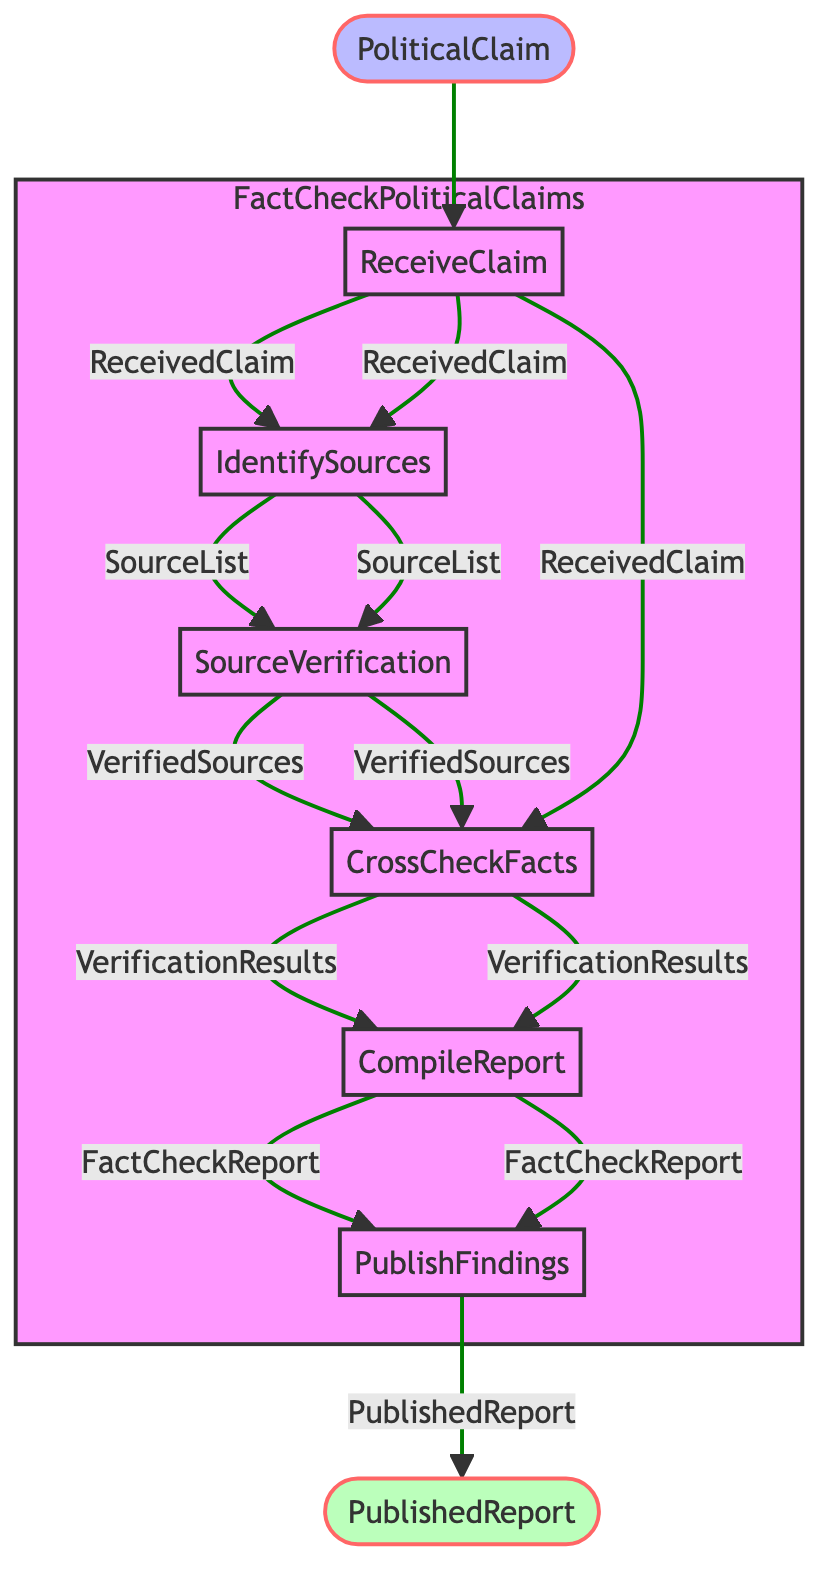What is the first step in the function? The first step listed in the diagram is "ReceiveClaim", which is indicated as the starting point.
Answer: ReceiveClaim How many outputs does the "CompileReport" step have? The "CompileReport" step produces one output, which is the "FactCheckReport".
Answer: One What does the "IdentifySources" step produce? This step produces a list of sources, known as "SourceList", which is the output of this step.
Answer: SourceList What step follows "CrossCheckFacts"? The step that follows "CrossCheckFacts" in the flowchart is "CompileReport".
Answer: CompileReport Which step involves verifying the credibility of sources? The step involved in verifying the credibility of sources is "SourceVerification".
Answer: SourceVerification What is the final output of the function? The final output produced by the function is "PublishedReport", which is the result of the last step.
Answer: PublishedReport Which input is required at the beginning of the function? The initial input required is "PoliticalClaim". This is the first input to enter the function.
Answer: PoliticalClaim How many steps are there in total? Counting all the steps from start to finish, there are six steps in total included in the flowchart.
Answer: Six What is the purpose of the "CrossCheckFacts" step? The purpose of the "CrossCheckFacts" step is to cross-check the political claim against the verified sources to ascertain its validity.
Answer: Cross-check claim 